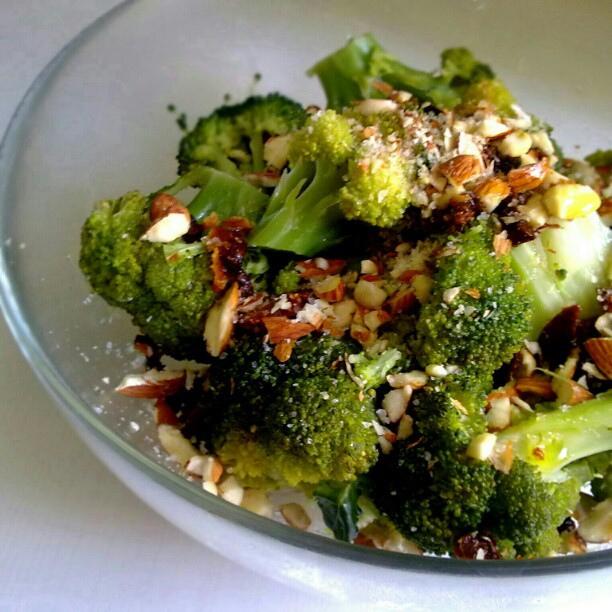What color is the bowl?
Short answer required. Clear. What color is the bowel?
Keep it brief. Clear. Is the broccoli cooked?
Concise answer only. Yes. What is the table made of?
Be succinct. Plastic. Are there water droplets on the bowl?
Concise answer only. No. Are the almonds chopped?
Be succinct. Yes. Are the vegetables fresh?
Keep it brief. Yes. Are there any nuts in the dish?
Keep it brief. Yes. 